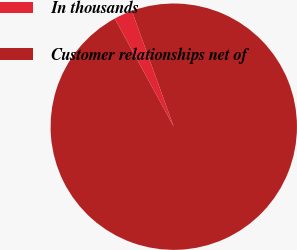Convert chart. <chart><loc_0><loc_0><loc_500><loc_500><pie_chart><fcel>In thousands<fcel>Customer relationships net of<nl><fcel>2.43%<fcel>97.57%<nl></chart> 